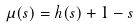<formula> <loc_0><loc_0><loc_500><loc_500>\mu ( s ) & = h ( s ) + 1 - s</formula> 